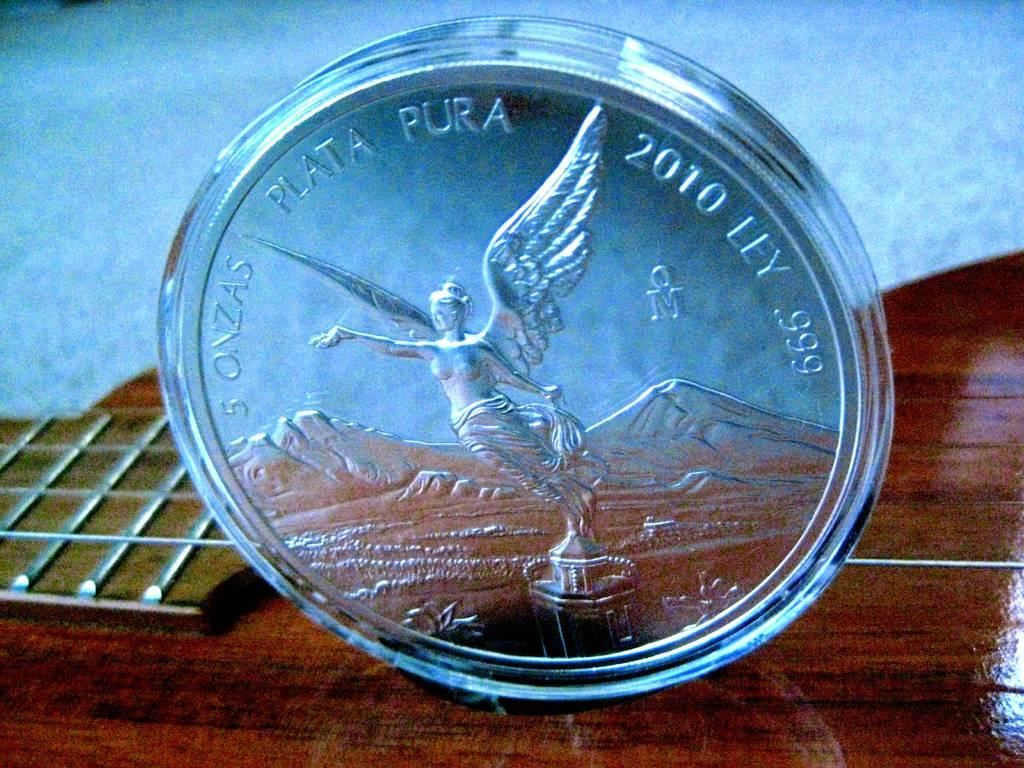<image>
Render a clear and concise summary of the photo. The writing on the silver coin indicates it is 5 ounces pure silver. 